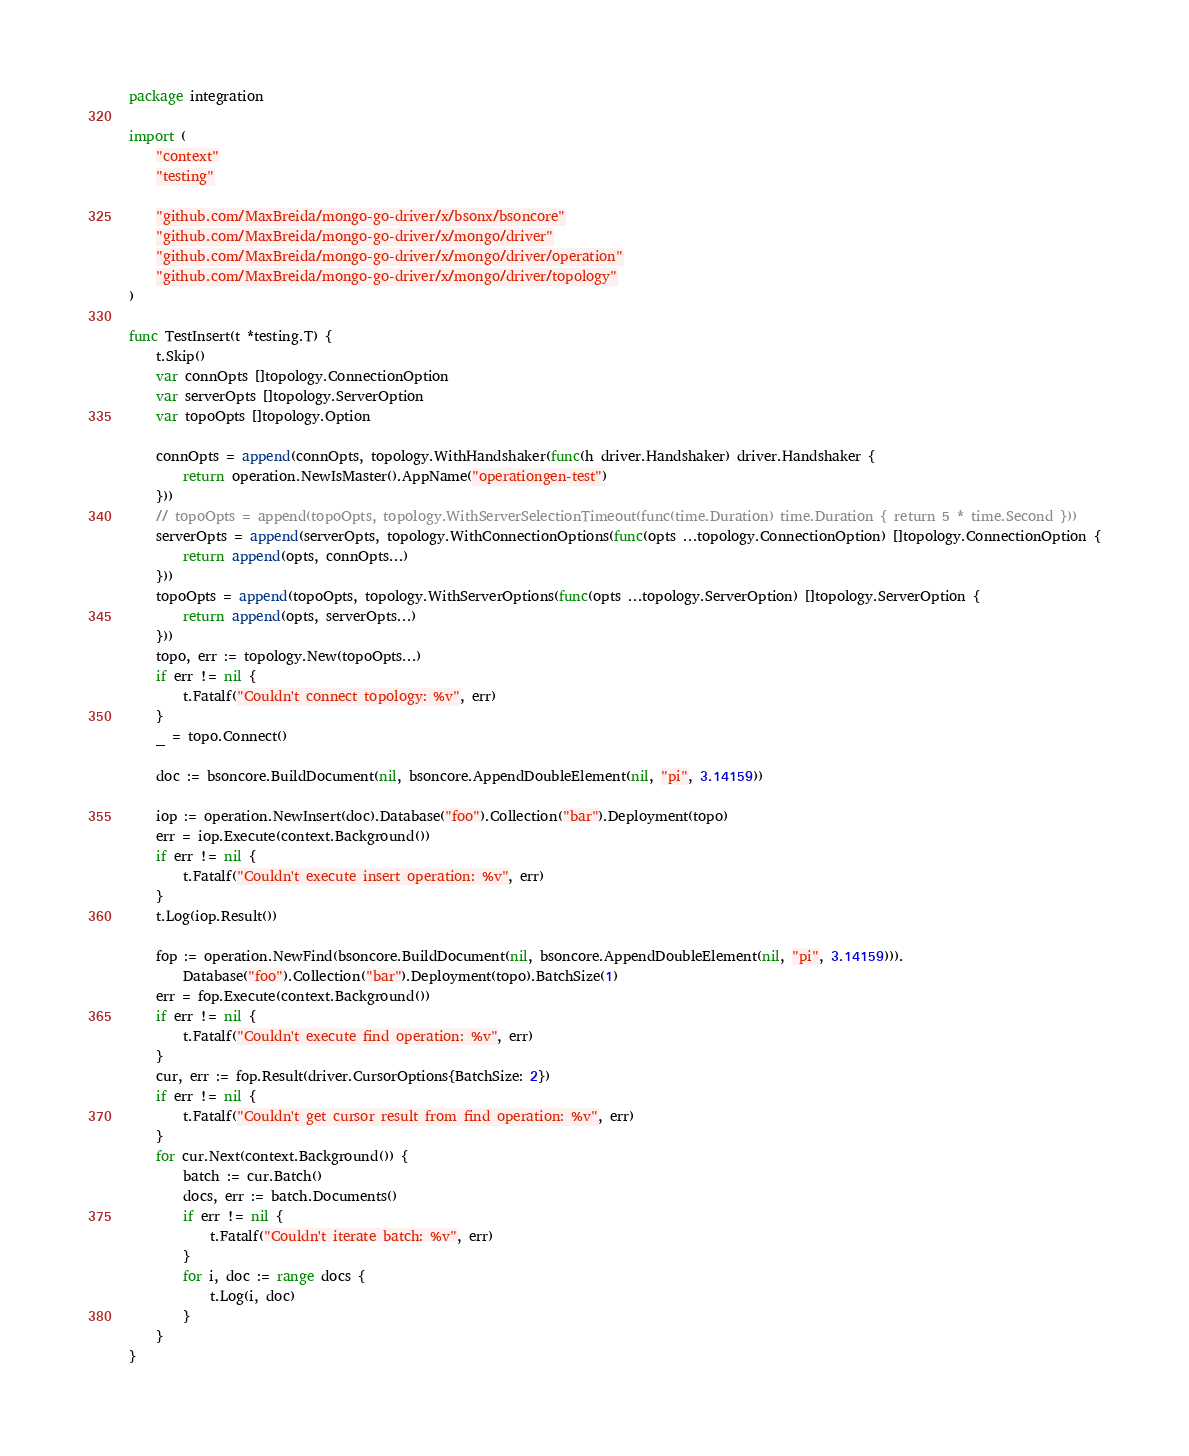Convert code to text. <code><loc_0><loc_0><loc_500><loc_500><_Go_>package integration

import (
	"context"
	"testing"

	"github.com/MaxBreida/mongo-go-driver/x/bsonx/bsoncore"
	"github.com/MaxBreida/mongo-go-driver/x/mongo/driver"
	"github.com/MaxBreida/mongo-go-driver/x/mongo/driver/operation"
	"github.com/MaxBreida/mongo-go-driver/x/mongo/driver/topology"
)

func TestInsert(t *testing.T) {
	t.Skip()
	var connOpts []topology.ConnectionOption
	var serverOpts []topology.ServerOption
	var topoOpts []topology.Option

	connOpts = append(connOpts, topology.WithHandshaker(func(h driver.Handshaker) driver.Handshaker {
		return operation.NewIsMaster().AppName("operationgen-test")
	}))
	// topoOpts = append(topoOpts, topology.WithServerSelectionTimeout(func(time.Duration) time.Duration { return 5 * time.Second }))
	serverOpts = append(serverOpts, topology.WithConnectionOptions(func(opts ...topology.ConnectionOption) []topology.ConnectionOption {
		return append(opts, connOpts...)
	}))
	topoOpts = append(topoOpts, topology.WithServerOptions(func(opts ...topology.ServerOption) []topology.ServerOption {
		return append(opts, serverOpts...)
	}))
	topo, err := topology.New(topoOpts...)
	if err != nil {
		t.Fatalf("Couldn't connect topology: %v", err)
	}
	_ = topo.Connect()

	doc := bsoncore.BuildDocument(nil, bsoncore.AppendDoubleElement(nil, "pi", 3.14159))

	iop := operation.NewInsert(doc).Database("foo").Collection("bar").Deployment(topo)
	err = iop.Execute(context.Background())
	if err != nil {
		t.Fatalf("Couldn't execute insert operation: %v", err)
	}
	t.Log(iop.Result())

	fop := operation.NewFind(bsoncore.BuildDocument(nil, bsoncore.AppendDoubleElement(nil, "pi", 3.14159))).
		Database("foo").Collection("bar").Deployment(topo).BatchSize(1)
	err = fop.Execute(context.Background())
	if err != nil {
		t.Fatalf("Couldn't execute find operation: %v", err)
	}
	cur, err := fop.Result(driver.CursorOptions{BatchSize: 2})
	if err != nil {
		t.Fatalf("Couldn't get cursor result from find operation: %v", err)
	}
	for cur.Next(context.Background()) {
		batch := cur.Batch()
		docs, err := batch.Documents()
		if err != nil {
			t.Fatalf("Couldn't iterate batch: %v", err)
		}
		for i, doc := range docs {
			t.Log(i, doc)
		}
	}
}
</code> 